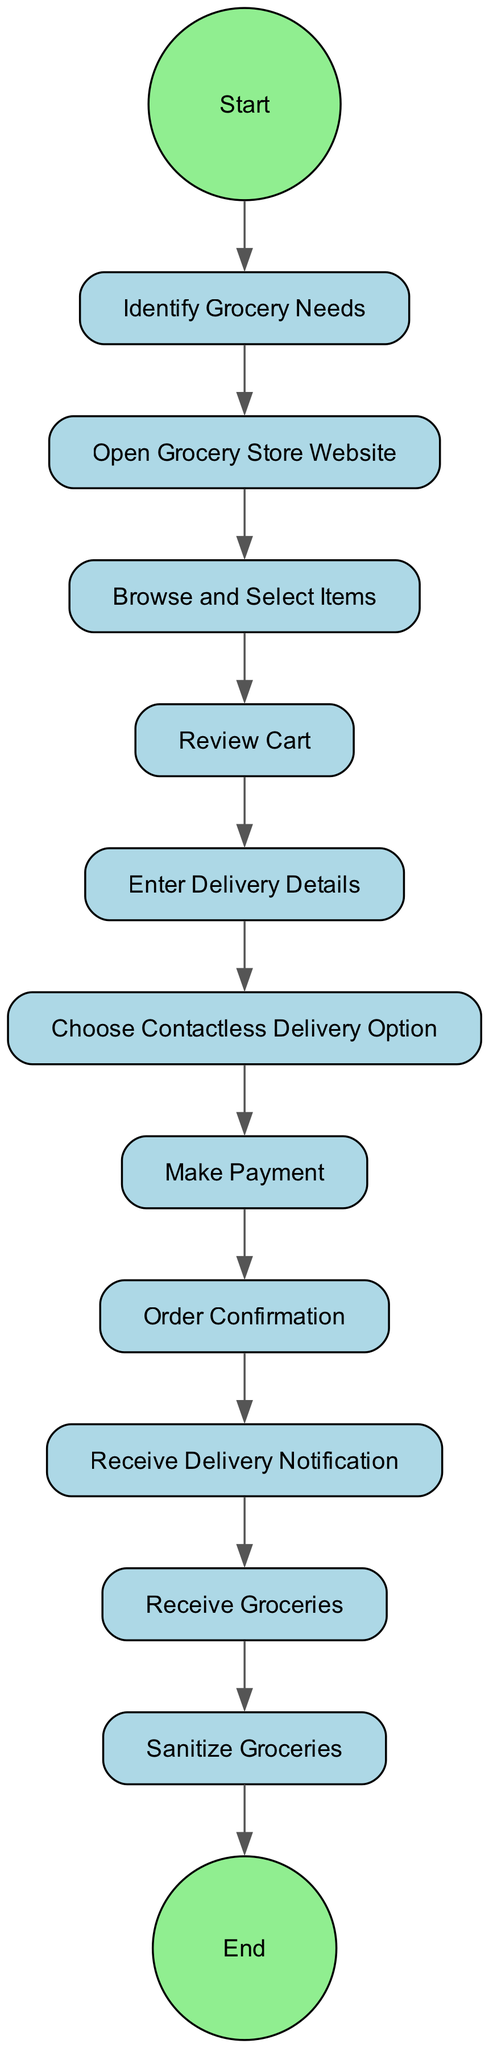What is the first activity in the diagram? The first activity is 'Identify Grocery Needs', which is the starting point of the grocery shopping process as depicted in the diagram.
Answer: Identify Grocery Needs How many total activities are in the diagram? By counting the activities listed, there are 11 activities that make up the complete grocery shopping process.
Answer: 11 What activity follows 'Review Cart'? After 'Review Cart', the next activity is 'Enter Delivery Details', which indicates the progression of the grocery shopping process.
Answer: Enter Delivery Details Which activity requires entering payment information? The activity that requires entering payment information is 'Make Payment', as it is the stage where the elderly woman completes her purchase.
Answer: Make Payment What type of delivery option is selected during the checkout process? The delivery option selected is 'Choose Contactless Delivery Option', reflecting the preference for safety during the pandemic.
Answer: Contactless Delivery Option What happens immediately after the 'Order Confirmation'? Immediately after 'Order Confirmation', the activity that follows is 'Receive Delivery Notification', which informs the elderly woman about her order status.
Answer: Receive Delivery Notification What is the last activity in the diagram? The last activity in the diagram is 'Sanitize Groceries', as it occurs after receiving the groceries and aims to ensure safety before putting them away.
Answer: Sanitize Groceries 